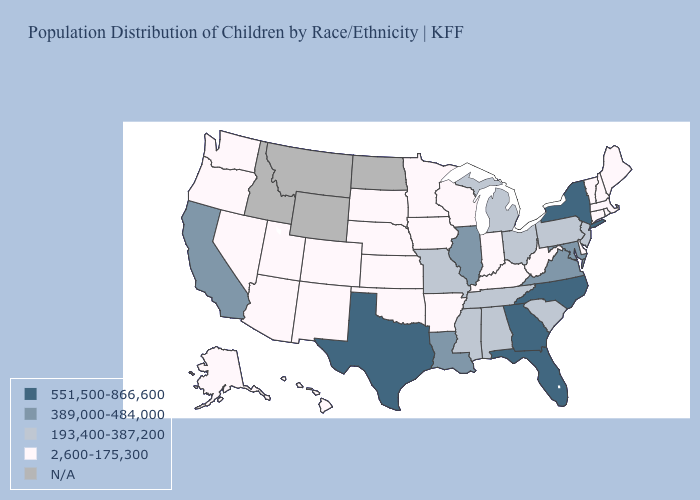What is the value of Iowa?
Be succinct. 2,600-175,300. Which states have the lowest value in the MidWest?
Quick response, please. Indiana, Iowa, Kansas, Minnesota, Nebraska, South Dakota, Wisconsin. Does Florida have the highest value in the USA?
Short answer required. Yes. Which states have the lowest value in the USA?
Be succinct. Alaska, Arizona, Arkansas, Colorado, Connecticut, Delaware, Hawaii, Indiana, Iowa, Kansas, Kentucky, Maine, Massachusetts, Minnesota, Nebraska, Nevada, New Hampshire, New Mexico, Oklahoma, Oregon, Rhode Island, South Dakota, Utah, Vermont, Washington, West Virginia, Wisconsin. Does Texas have the highest value in the USA?
Short answer required. Yes. What is the lowest value in states that border Virginia?
Answer briefly. 2,600-175,300. Which states hav the highest value in the MidWest?
Give a very brief answer. Illinois. How many symbols are there in the legend?
Be succinct. 5. Name the states that have a value in the range 2,600-175,300?
Write a very short answer. Alaska, Arizona, Arkansas, Colorado, Connecticut, Delaware, Hawaii, Indiana, Iowa, Kansas, Kentucky, Maine, Massachusetts, Minnesota, Nebraska, Nevada, New Hampshire, New Mexico, Oklahoma, Oregon, Rhode Island, South Dakota, Utah, Vermont, Washington, West Virginia, Wisconsin. What is the lowest value in the USA?
Write a very short answer. 2,600-175,300. Which states have the highest value in the USA?
Quick response, please. Florida, Georgia, New York, North Carolina, Texas. How many symbols are there in the legend?
Quick response, please. 5. Does Kentucky have the highest value in the USA?
Be succinct. No. What is the value of West Virginia?
Give a very brief answer. 2,600-175,300. Which states have the lowest value in the USA?
Answer briefly. Alaska, Arizona, Arkansas, Colorado, Connecticut, Delaware, Hawaii, Indiana, Iowa, Kansas, Kentucky, Maine, Massachusetts, Minnesota, Nebraska, Nevada, New Hampshire, New Mexico, Oklahoma, Oregon, Rhode Island, South Dakota, Utah, Vermont, Washington, West Virginia, Wisconsin. 